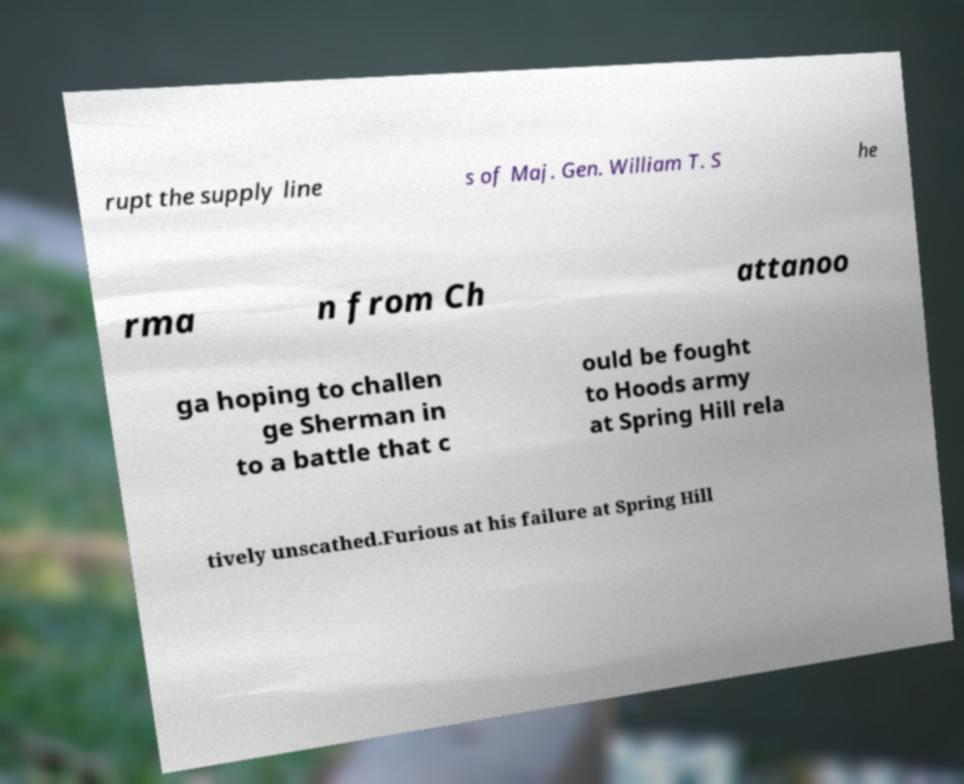There's text embedded in this image that I need extracted. Can you transcribe it verbatim? rupt the supply line s of Maj. Gen. William T. S he rma n from Ch attanoo ga hoping to challen ge Sherman in to a battle that c ould be fought to Hoods army at Spring Hill rela tively unscathed.Furious at his failure at Spring Hill 